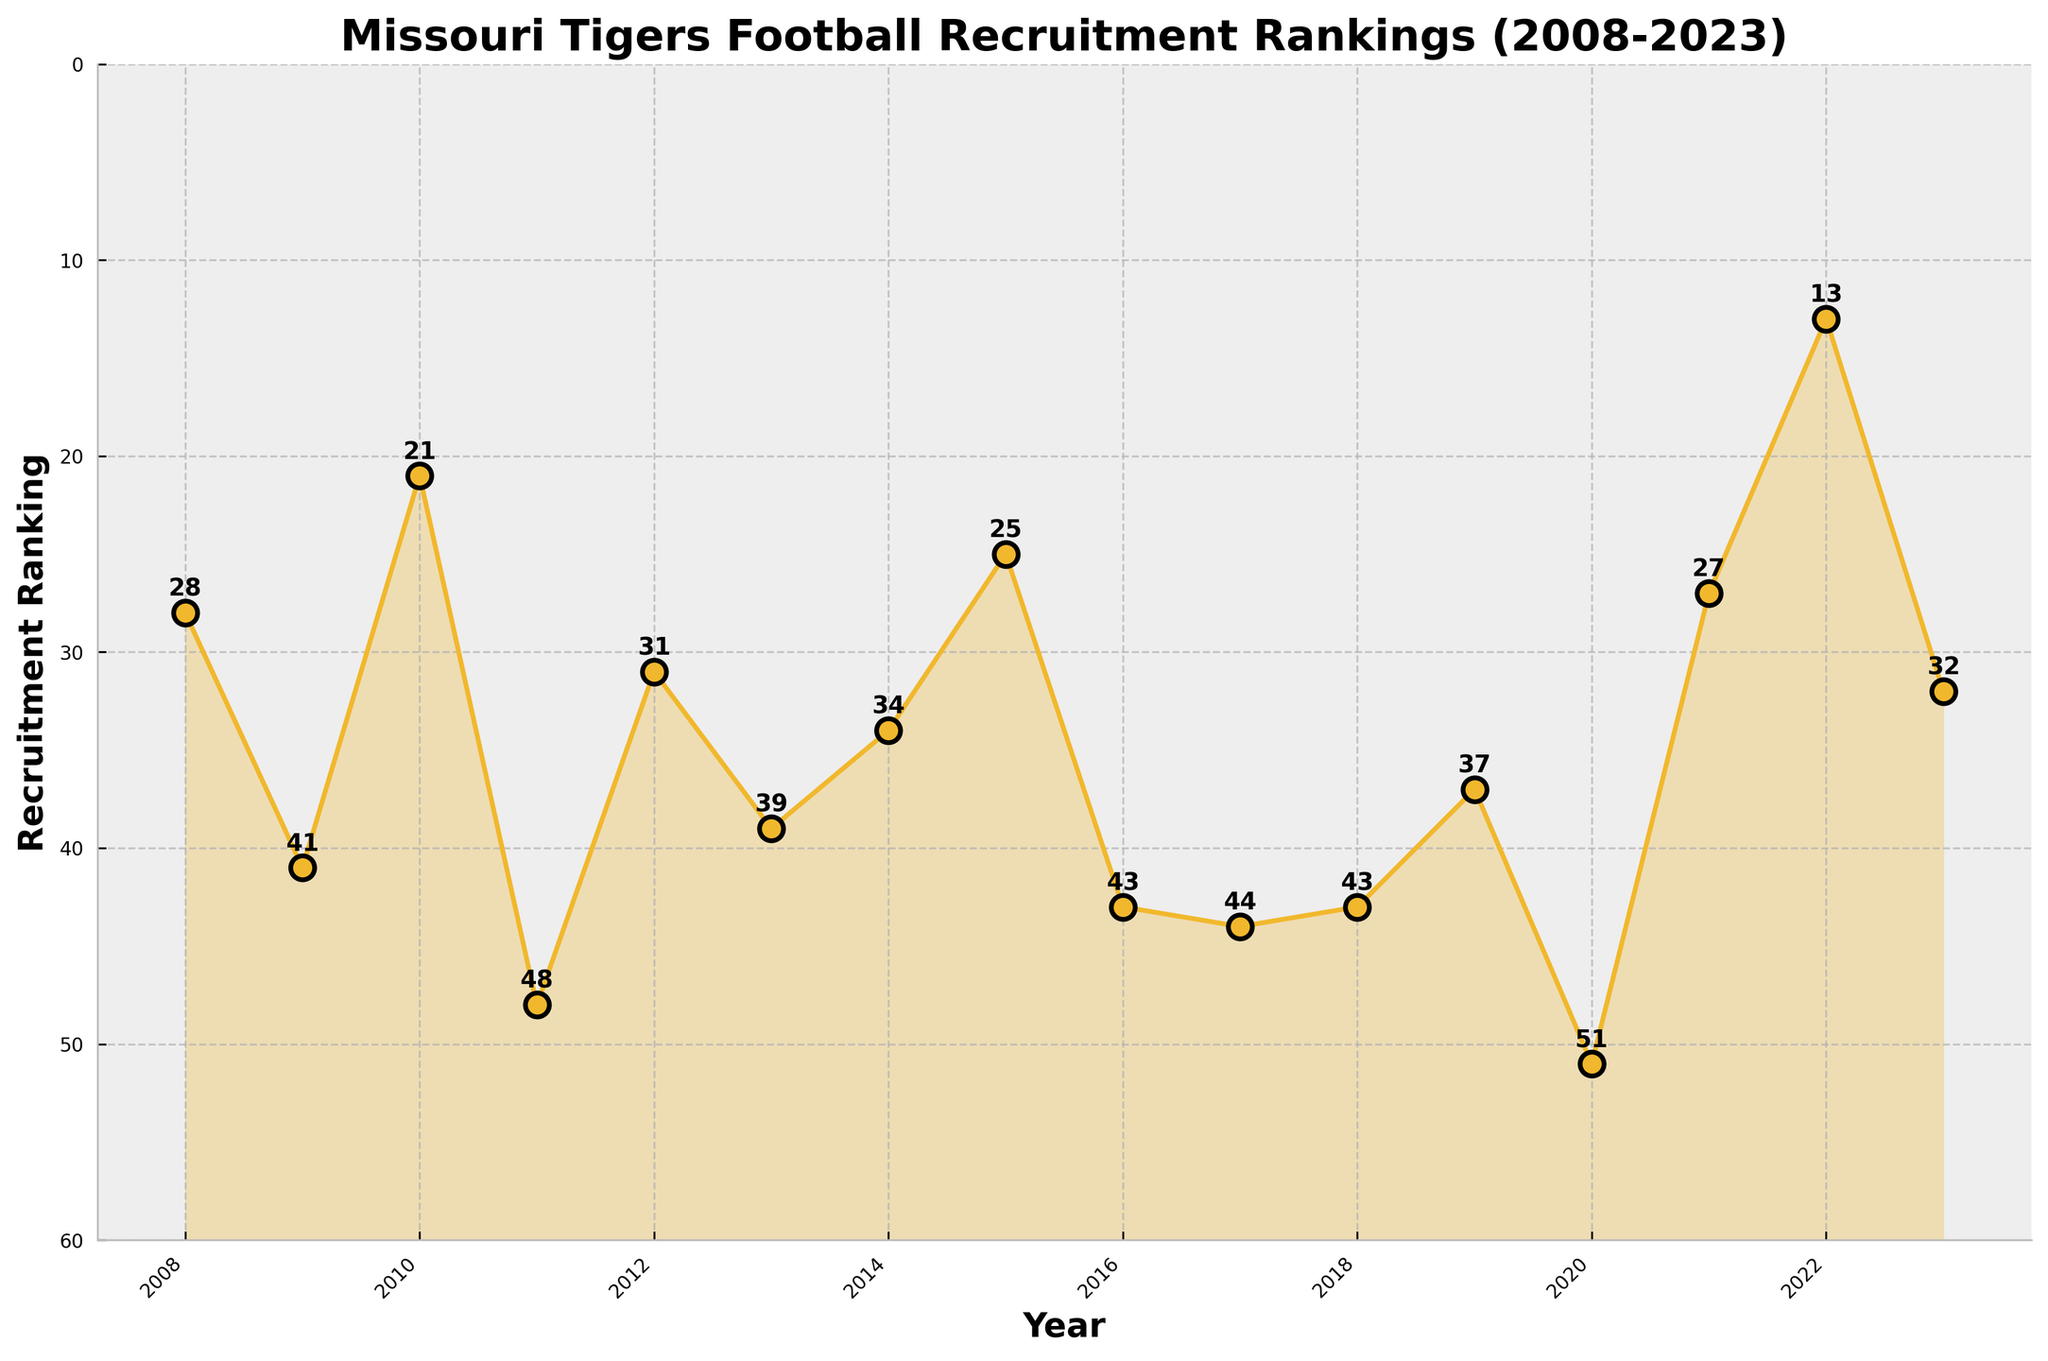How many years of data are displayed in the plot? Count the number of data points or years along the x-axis.
Answer: 16 What color is used to plot the recruitment rankings? Observe the line color and filled area in the chart.
Answer: Yellow What year has the highest recruitment ranking? Identify the point on the plot where the recruitment ranking is the highest (closest to 0 on the y-axis).
Answer: 2022 Which year shows a recruitment ranking of 25? Look for the data point labeled 25 along the y-axis and check its corresponding year.
Answer: 2015 How does the recruitment ranking trend change from 2020 to 2021? Compare the data points for 2020 and 2021. Notice whether the line moves up or down between these points.
Answer: It improves What’s the average recruitment ranking over the entire period? Sum all the recruitment rankings and divide by the number of years. Calculation: (28 + 41 + 21 + 48 + 31 + 39 + 34 + 25 + 43 + 44 + 43 + 37 + 51 + 27 + 13 + 32) / 16 = 32.75
Answer: 32.75 Which two consecutive years had the largest increase in recruitment ranking? Check the differences between each pair of consecutive years and identify the largest increase. From 2021 to 2022, the change is from 27 to 13.
Answer: 2021 to 2022 In which year did Missouri Tigers recruitment ranking experience the sharpest decline from the previous year? Identify the year with the biggest increase in the ranking value compared to the previous year. From 2020 to 2021, the change is from 51 to 27.
Answer: 2020 to 2021 What is the recruitment ranking trend between 2016 and 2018? Note the continuous ranking values in 2016, 2017, and 2018 and describe if it is generally increasing, decreasing, or stable.
Answer: Stable How often does the recruitment ranking flip direction from one year to the next? (i.e., switch from increasing to decreasing or vice versa) Count the number of times the direction changes by comparing the rankings year over year.
Answer: 9 times 